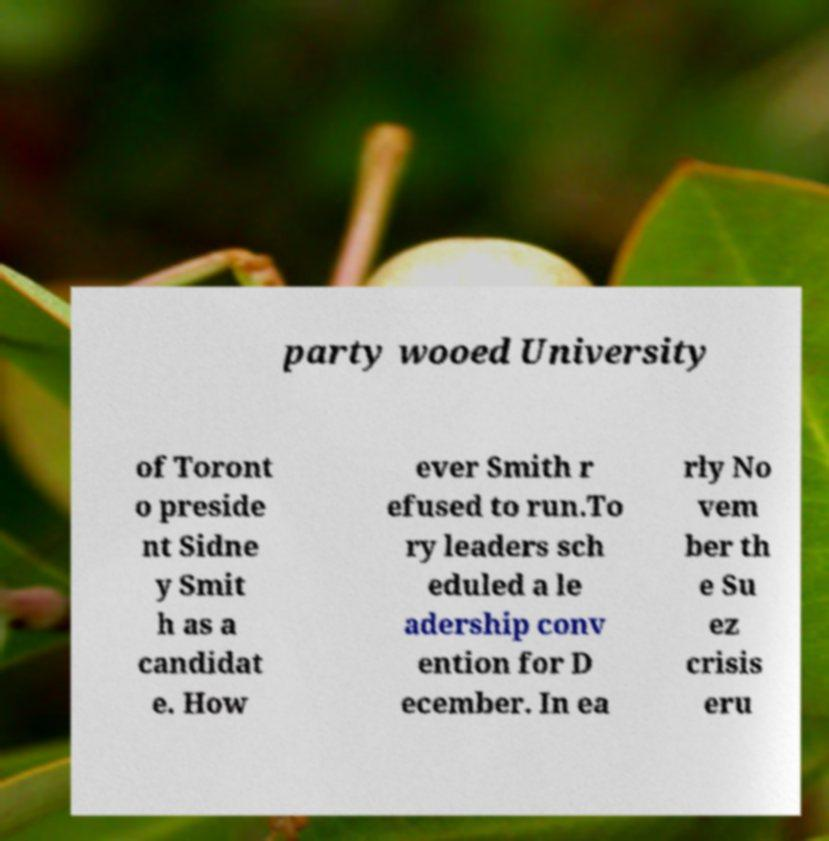For documentation purposes, I need the text within this image transcribed. Could you provide that? party wooed University of Toront o preside nt Sidne y Smit h as a candidat e. How ever Smith r efused to run.To ry leaders sch eduled a le adership conv ention for D ecember. In ea rly No vem ber th e Su ez crisis eru 